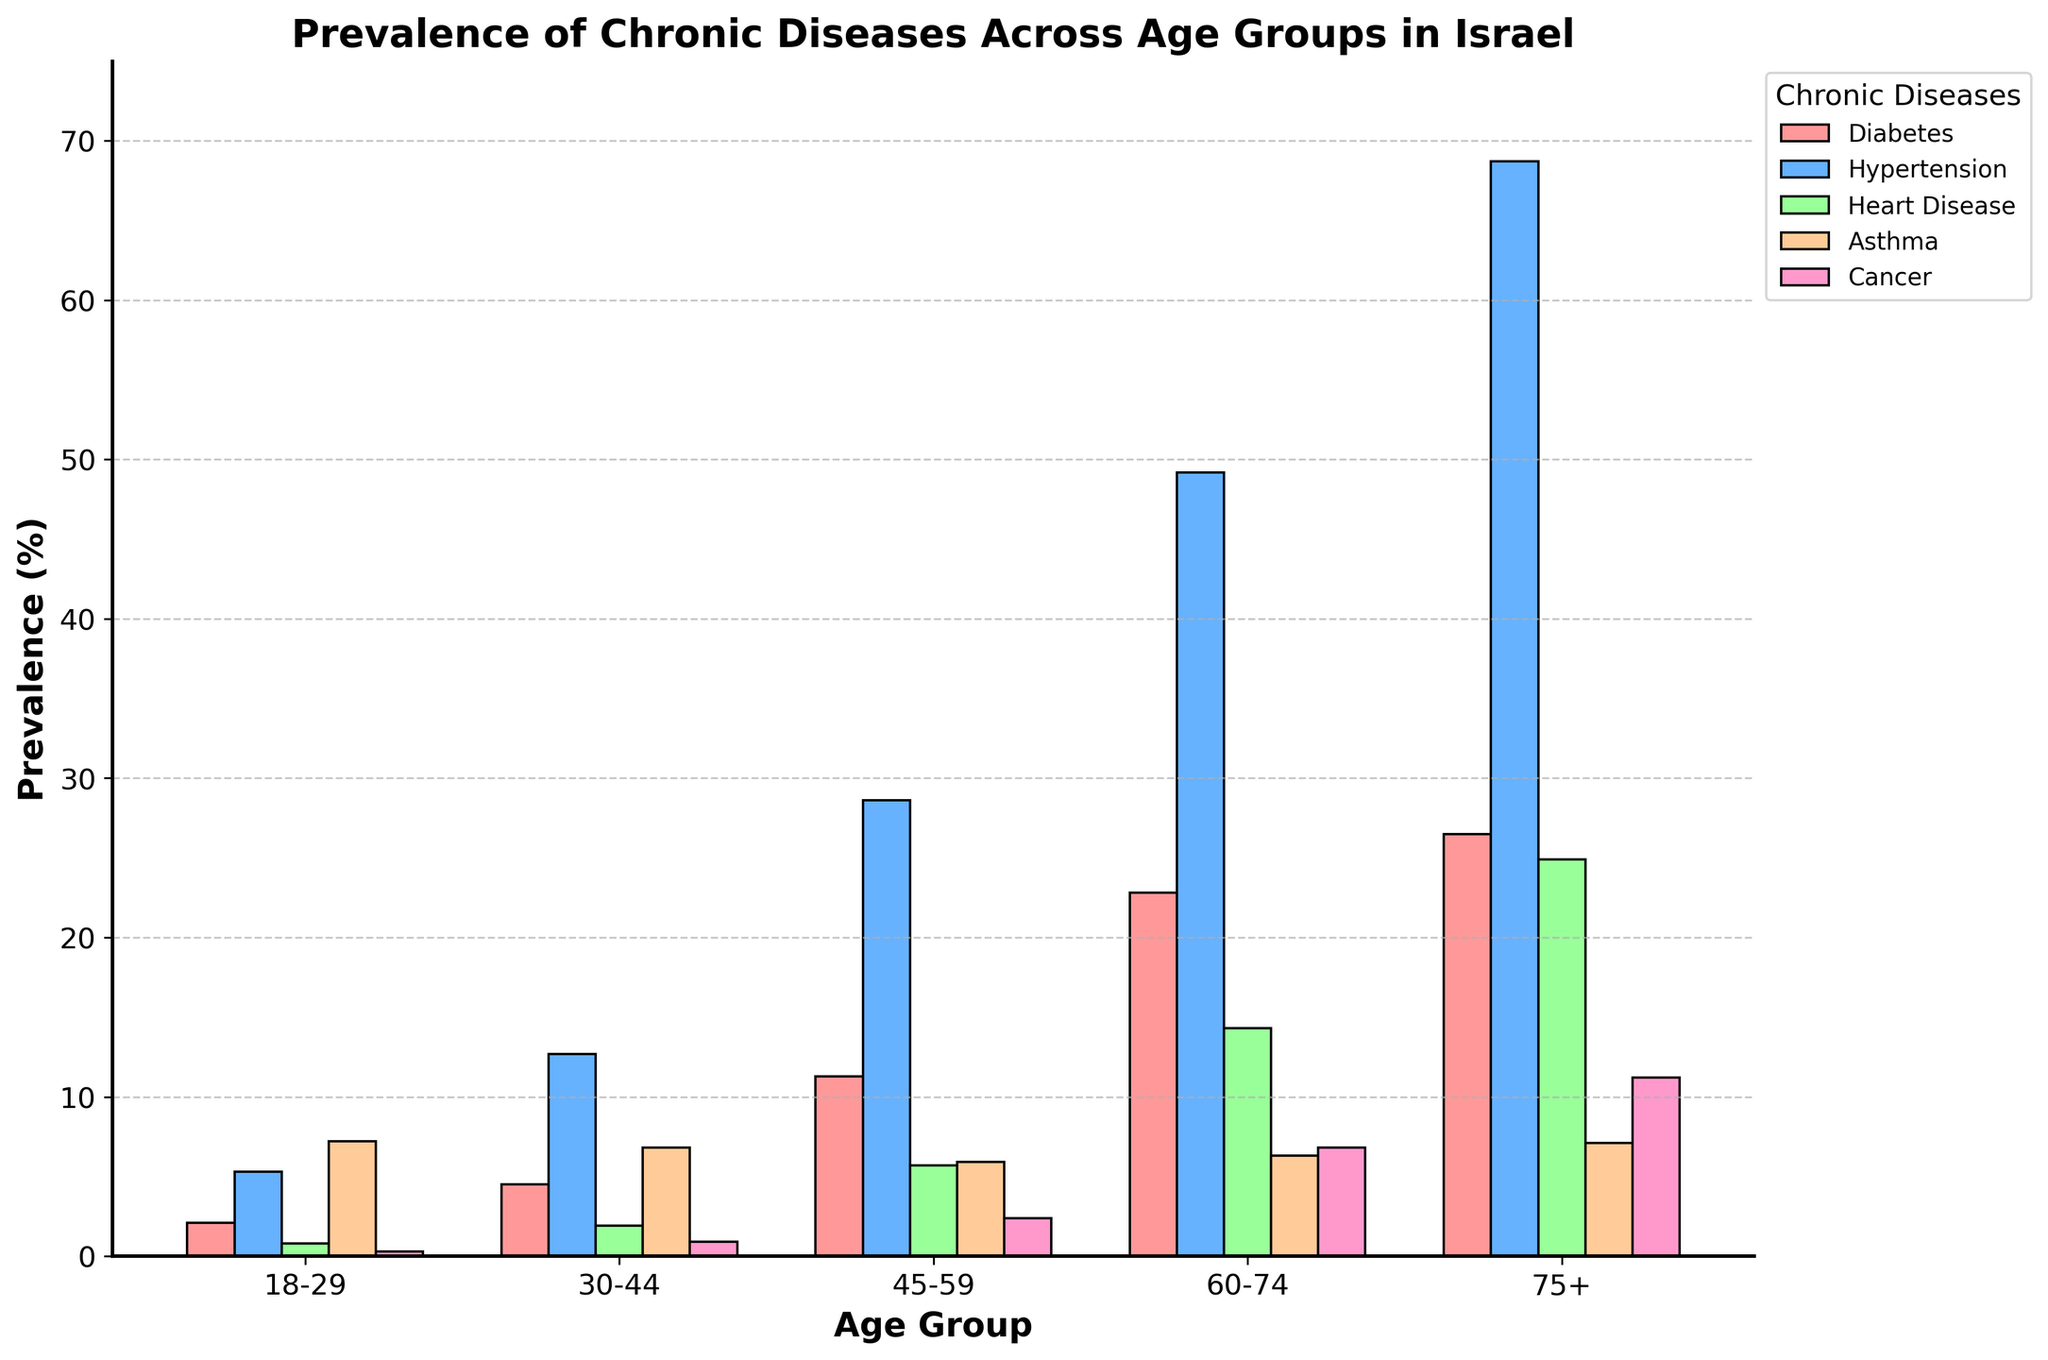What age group has the highest prevalence of diabetes? By visually inspecting the height of the bars representing diabetes across all age groups, the highest bar is for the 75+ age group.
Answer: 75+ Which chronic disease has the lowest prevalence in the 45-59 age group? Checking the heights of all bars for the 45-59 age group, the smallest one corresponds to Cancer.
Answer: Cancer Comparing the 30-44 and 45-59 age groups, which group has a higher prevalence of heart disease? The bar for heart disease in the 45-59 age group is taller than the one for the 30-44 age group.
Answer: 45-59 What is the total prevalence of Diabetes and Hypertension in the 60-74 age group? Add the prevalence values of Diabetes (22.8) and Hypertension (49.2) in the 60-74 age group: 22.8 + 49.2 = 72.
Answer: 72 In which age group is the difference between the prevalence of Hypertension and Asthma the greatest? Calculate the difference between Hypertension and Asthma for each age group:
18-29: 5.3 - 7.2 = -1.9
30-44: 12.7 - 6.8 = 5.9
45-59: 28.6 - 5.9 = 22.7
60-74: 49.2 - 6.3 = 42.9
75+: 68.7 - 7.1 = 61.6
The greatest difference is in the 75+ age group.
Answer: 75+ What is the average prevalence of cancer across all age groups? Sum the prevalence values of Cancer and divide by the number of age groups:
(0.3 + 0.9 + 2.4 + 6.8 + 11.2) / 5 = 21.6 / 5 = 4.32
Answer: 4.32 Which chronic disease shows the most consistent prevalence across all age groups? By comparing the bar heights visually, Asthma seems to fluctuate the least among all age groups.
Answer: Asthma Is the prevalence of heart disease in the 75+ age group greater than the prevalence of hypertension in the 18-29 age group? The bar for heart disease in the 75+ age group is taller than the bar for hypertension in the 18-29 age group (24.9 vs. 5.3).
Answer: Yes 